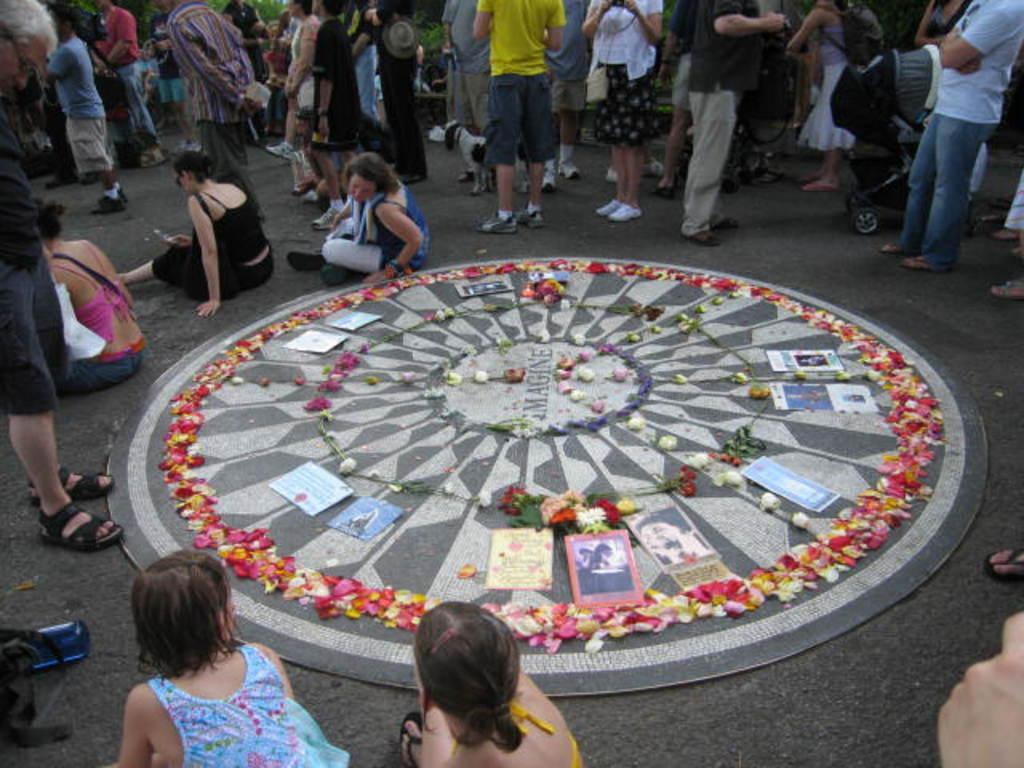Can you describe this image briefly? In the foreground of this image, there are few posters, flowers and petals on a circular object which is on the road. There are people standing, sitting and walking around it. We can also see a dog and greenery in the background. 